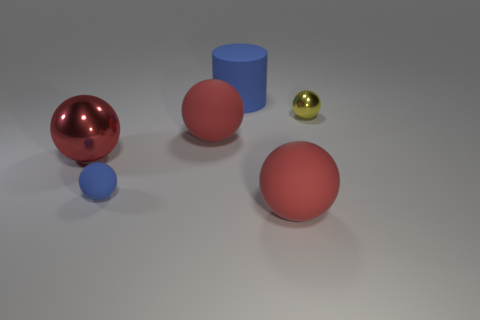There is a shiny object that is in front of the yellow shiny sphere; is its shape the same as the big blue matte object?
Your response must be concise. No. Is the number of small yellow shiny spheres less than the number of purple cubes?
Your response must be concise. No. How many large things have the same color as the tiny rubber object?
Provide a short and direct response. 1. What material is the object that is the same color as the rubber cylinder?
Your answer should be very brief. Rubber. Do the tiny metal thing and the large sphere that is in front of the big shiny thing have the same color?
Give a very brief answer. No. Are there more small yellow metal balls than red matte spheres?
Keep it short and to the point. No. There is another shiny thing that is the same shape as the yellow object; what size is it?
Your answer should be very brief. Large. Does the small yellow sphere have the same material as the large red object that is right of the large blue object?
Keep it short and to the point. No. How many objects are small blue spheres or rubber spheres?
Provide a succinct answer. 3. There is a blue thing behind the tiny yellow thing; does it have the same size as the matte object in front of the small blue thing?
Give a very brief answer. Yes. 